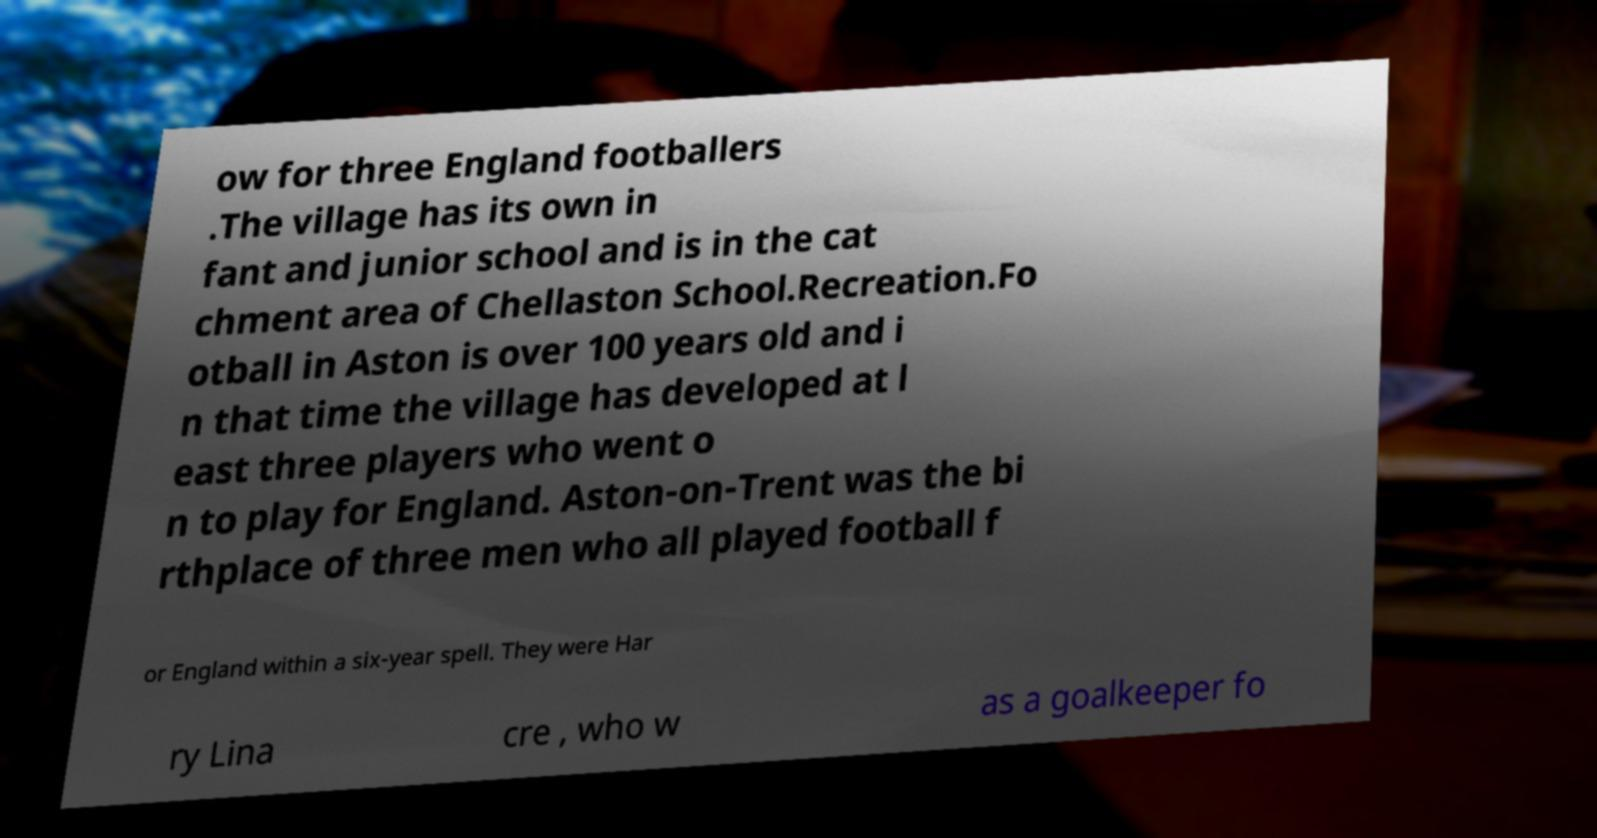Could you assist in decoding the text presented in this image and type it out clearly? ow for three England footballers .The village has its own in fant and junior school and is in the cat chment area of Chellaston School.Recreation.Fo otball in Aston is over 100 years old and i n that time the village has developed at l east three players who went o n to play for England. Aston-on-Trent was the bi rthplace of three men who all played football f or England within a six-year spell. They were Har ry Lina cre , who w as a goalkeeper fo 